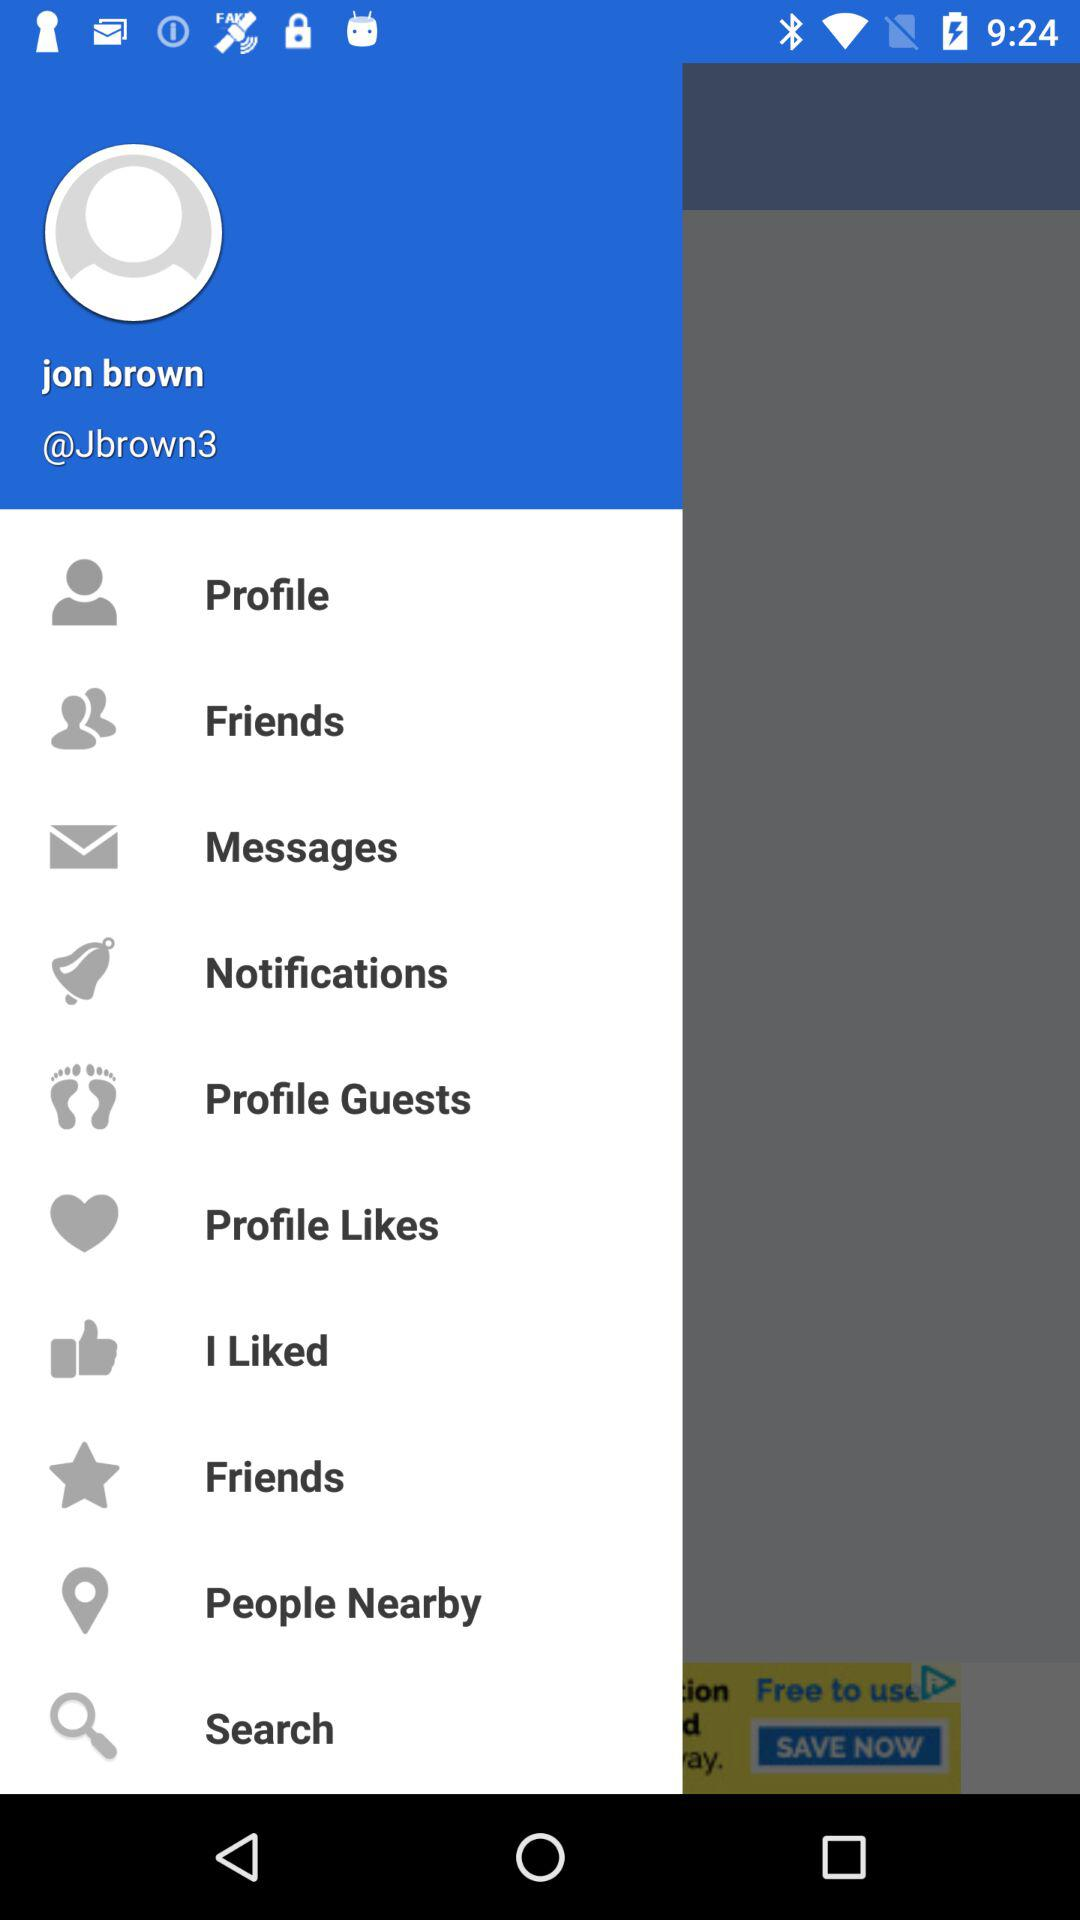What is the user name? The user name is Jon Brown. 